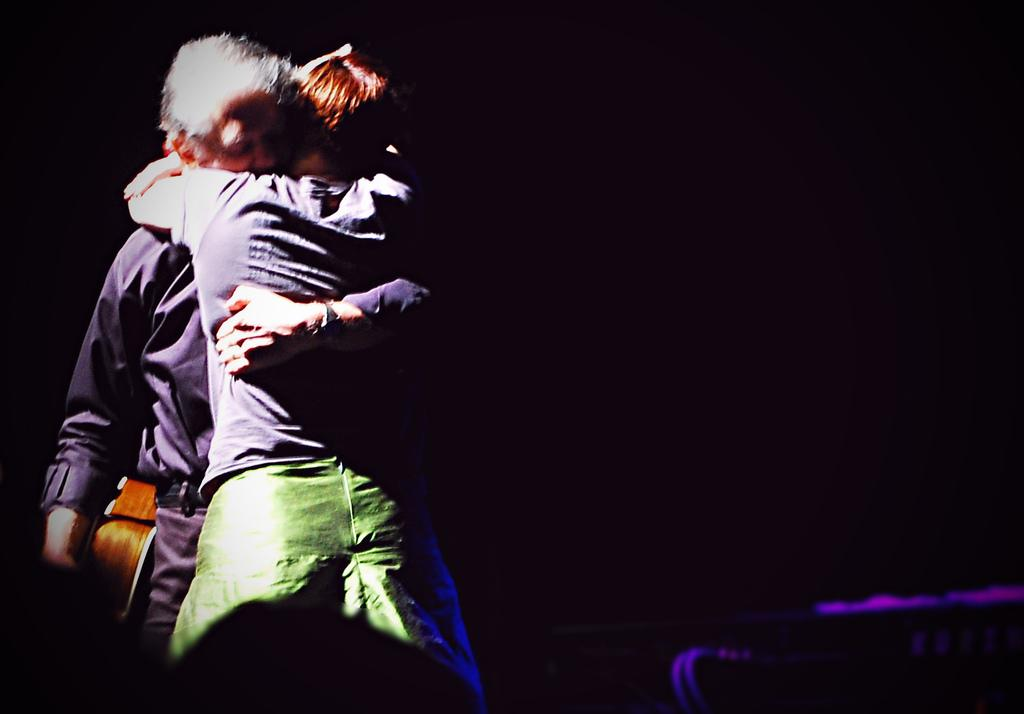How many people are in the image? There are two persons in the image. What are the two persons doing in the image? The two persons are hugging each other. Can you describe the object being held by one of the persons? Unfortunately, the object cannot be described in detail as it is not clearly visible in the image. What is the color of the background in the image? The background of the image is dark. What is the condition of the committee in the image? There is no committee present in the image, so it is not possible to determine the condition of any committee. Can you tell me how many fangs are visible in the image? There are no fangs visible in the image. 